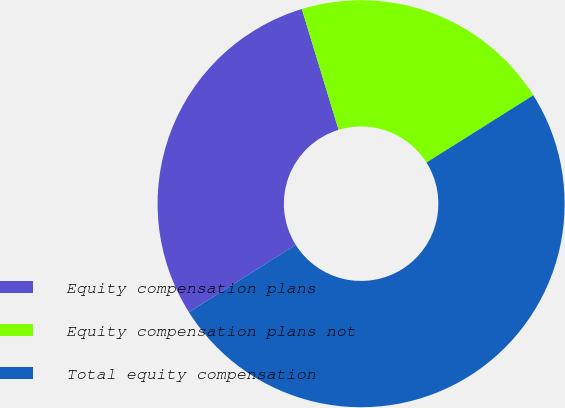Convert chart to OTSL. <chart><loc_0><loc_0><loc_500><loc_500><pie_chart><fcel>Equity compensation plans<fcel>Equity compensation plans not<fcel>Total equity compensation<nl><fcel>29.24%<fcel>20.76%<fcel>50.0%<nl></chart> 